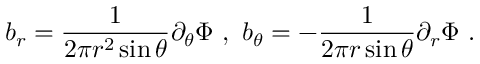<formula> <loc_0><loc_0><loc_500><loc_500>b _ { r } = \frac { 1 } { 2 \pi r ^ { 2 } \sin \theta } { \partial _ { \theta } \Phi } \ , \ b _ { \theta } = - \frac { 1 } { 2 \pi r \sin \theta } { \partial _ { r } \Phi } \ .</formula> 